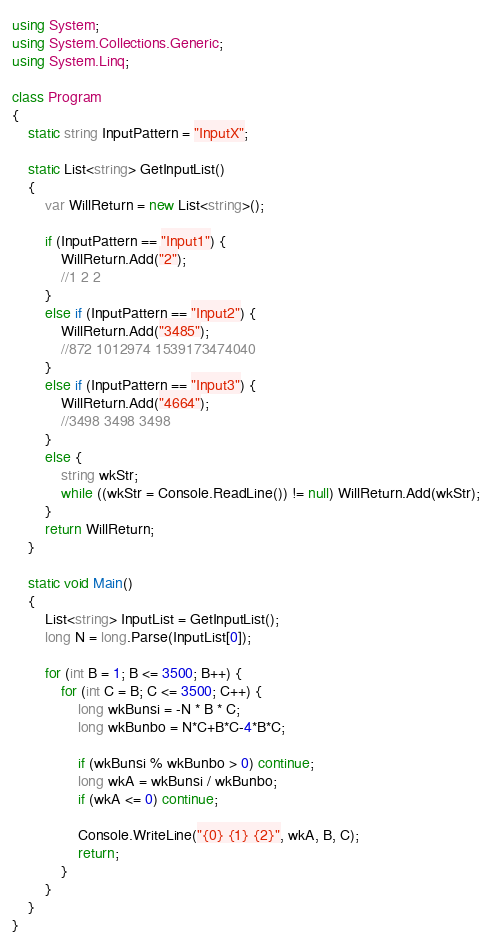<code> <loc_0><loc_0><loc_500><loc_500><_C#_>using System;
using System.Collections.Generic;
using System.Linq;

class Program
{
    static string InputPattern = "InputX";

    static List<string> GetInputList()
    {
        var WillReturn = new List<string>();

        if (InputPattern == "Input1") {
            WillReturn.Add("2");
            //1 2 2
        }
        else if (InputPattern == "Input2") {
            WillReturn.Add("3485");
            //872 1012974 1539173474040
        }
        else if (InputPattern == "Input3") {
            WillReturn.Add("4664");
            //3498 3498 3498
        }
        else {
            string wkStr;
            while ((wkStr = Console.ReadLine()) != null) WillReturn.Add(wkStr);
        }
        return WillReturn;
    }

    static void Main()
    {
        List<string> InputList = GetInputList();
        long N = long.Parse(InputList[0]);

        for (int B = 1; B <= 3500; B++) {
            for (int C = B; C <= 3500; C++) {
                long wkBunsi = -N * B * C;
                long wkBunbo = N*C+B*C-4*B*C;

                if (wkBunsi % wkBunbo > 0) continue;
                long wkA = wkBunsi / wkBunbo;
                if (wkA <= 0) continue;

                Console.WriteLine("{0} {1} {2}", wkA, B, C);
                return;
            }
        }
    }
}
</code> 